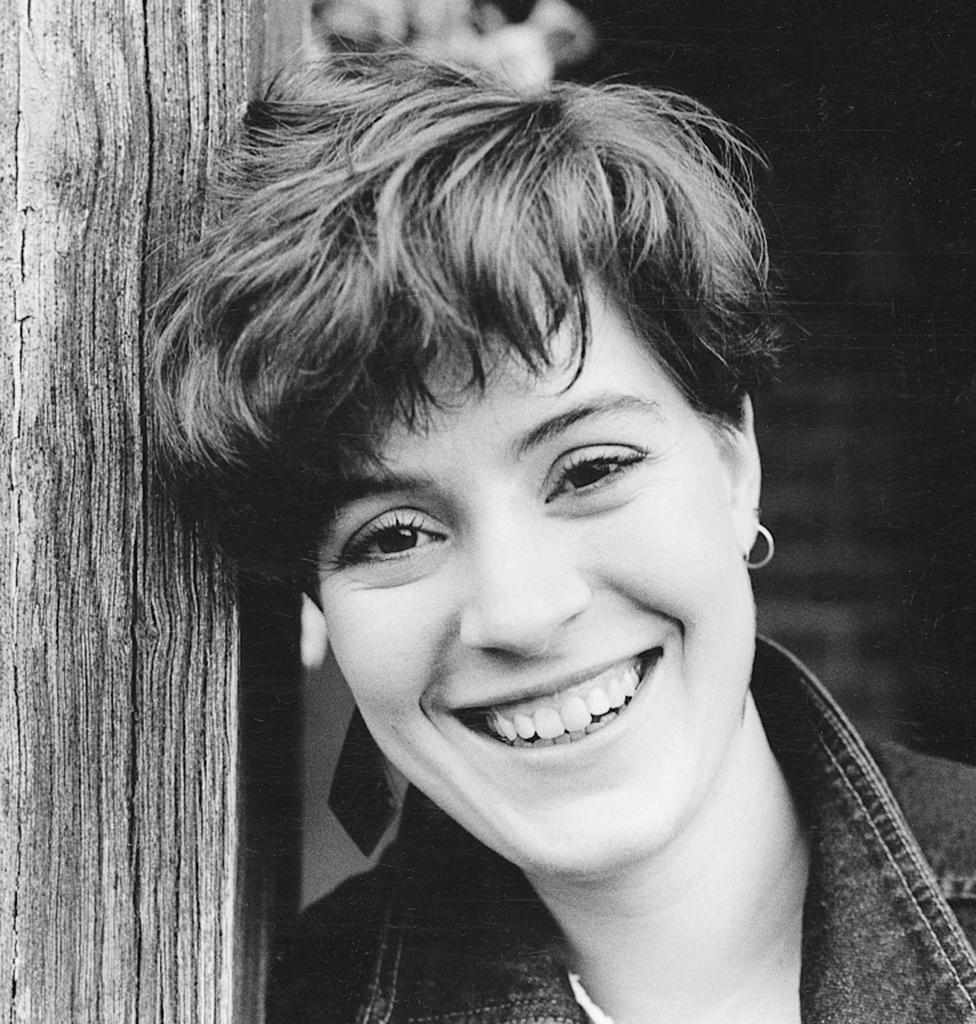What is the color scheme of the image? The image is black and white. Can you describe the main subject of the image? There is a person in the image. What part of the person is visible in the image? Only the face of the person is visible. What expression does the person have in the image? The person is smiling. How many dimes can be seen on the person's lip in the image? There are no dimes or lips visible in the image, as only the person's face is visible, and it is a black and white image. 